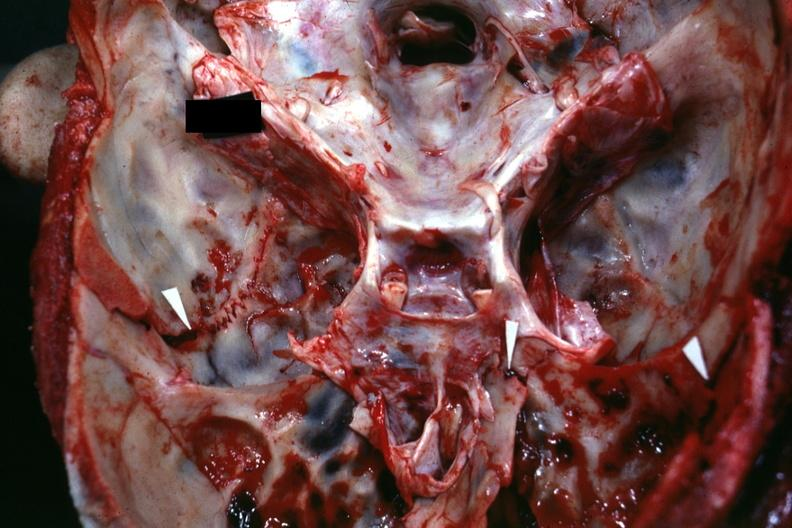what is present?
Answer the question using a single word or phrase. Basilar skull fracture 